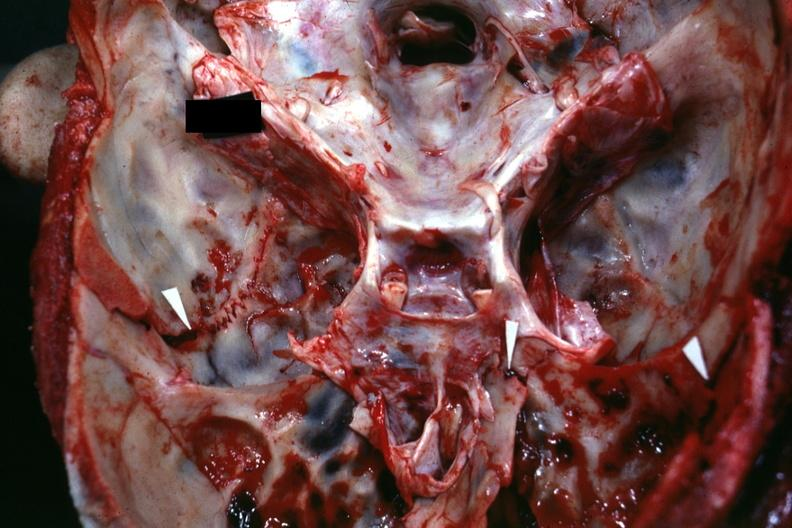what is present?
Answer the question using a single word or phrase. Basilar skull fracture 